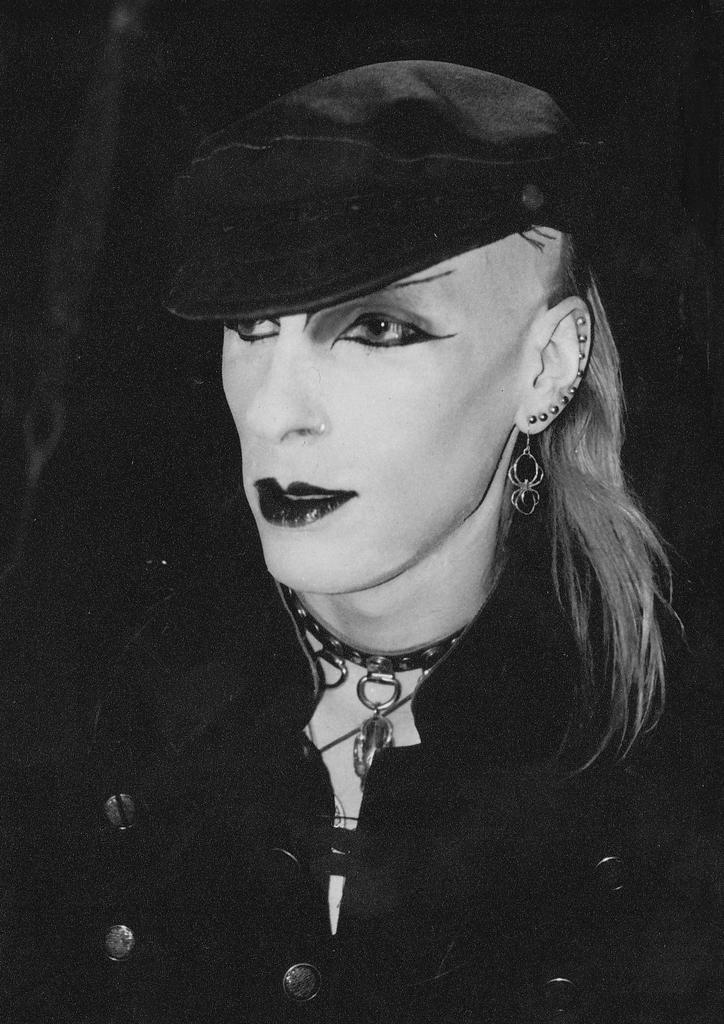Could you give a brief overview of what you see in this image? In this image I can see a person and I can also some jewellery and the image is in black and white. 